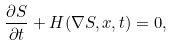Convert formula to latex. <formula><loc_0><loc_0><loc_500><loc_500>\frac { \partial S } { \partial t } + H ( \nabla S , x , t ) = 0 ,</formula> 